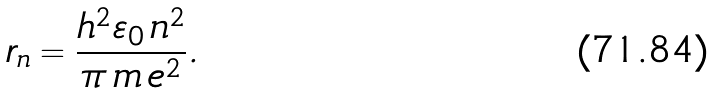<formula> <loc_0><loc_0><loc_500><loc_500>r _ { n } = \frac { h ^ { 2 } \varepsilon _ { 0 } \, n ^ { 2 } } { \pi \, m \, e ^ { 2 } } .</formula> 